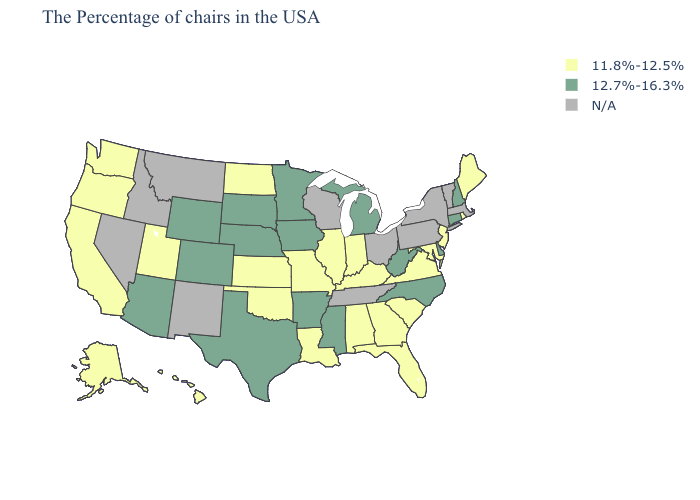What is the highest value in the West ?
Be succinct. 12.7%-16.3%. Name the states that have a value in the range 12.7%-16.3%?
Quick response, please. New Hampshire, Connecticut, Delaware, North Carolina, West Virginia, Michigan, Mississippi, Arkansas, Minnesota, Iowa, Nebraska, Texas, South Dakota, Wyoming, Colorado, Arizona. Name the states that have a value in the range N/A?
Give a very brief answer. Massachusetts, Vermont, New York, Pennsylvania, Ohio, Tennessee, Wisconsin, New Mexico, Montana, Idaho, Nevada. What is the value of Rhode Island?
Keep it brief. 11.8%-12.5%. Does Virginia have the lowest value in the USA?
Concise answer only. Yes. Name the states that have a value in the range 11.8%-12.5%?
Be succinct. Maine, Rhode Island, New Jersey, Maryland, Virginia, South Carolina, Florida, Georgia, Kentucky, Indiana, Alabama, Illinois, Louisiana, Missouri, Kansas, Oklahoma, North Dakota, Utah, California, Washington, Oregon, Alaska, Hawaii. Name the states that have a value in the range 11.8%-12.5%?
Be succinct. Maine, Rhode Island, New Jersey, Maryland, Virginia, South Carolina, Florida, Georgia, Kentucky, Indiana, Alabama, Illinois, Louisiana, Missouri, Kansas, Oklahoma, North Dakota, Utah, California, Washington, Oregon, Alaska, Hawaii. Which states have the lowest value in the USA?
Write a very short answer. Maine, Rhode Island, New Jersey, Maryland, Virginia, South Carolina, Florida, Georgia, Kentucky, Indiana, Alabama, Illinois, Louisiana, Missouri, Kansas, Oklahoma, North Dakota, Utah, California, Washington, Oregon, Alaska, Hawaii. Among the states that border Kansas , does Oklahoma have the highest value?
Keep it brief. No. What is the lowest value in the South?
Write a very short answer. 11.8%-12.5%. What is the value of Kansas?
Write a very short answer. 11.8%-12.5%. What is the value of Wyoming?
Write a very short answer. 12.7%-16.3%. 